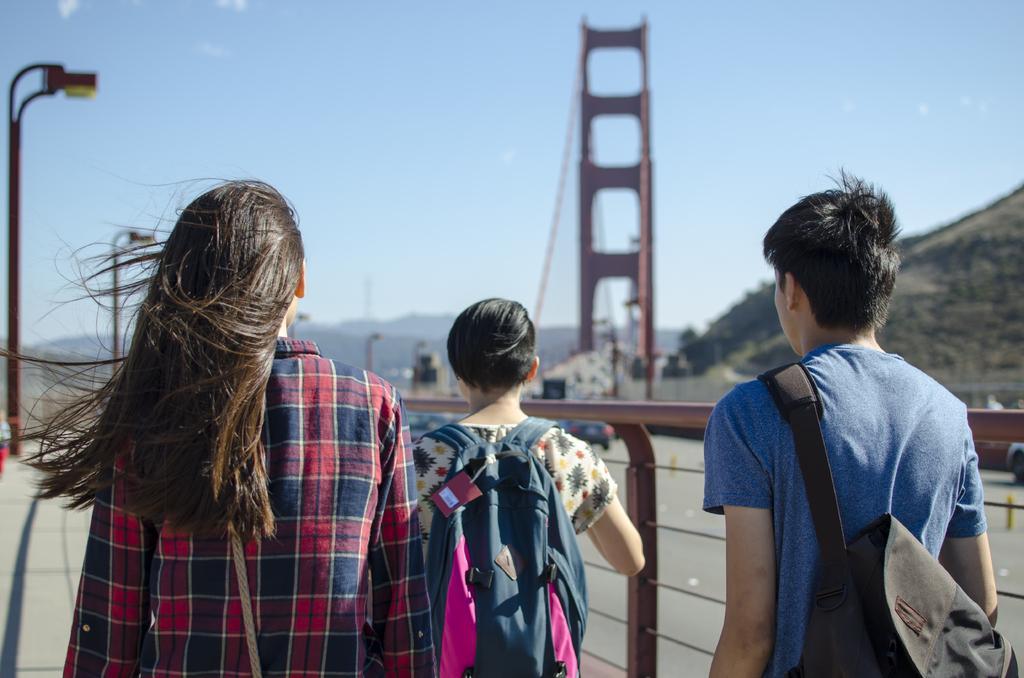Describe this image in one or two sentences. In this image we can see persons walking on the road. In the background we can see car, bridge, poles, hill, sky and clouds. 